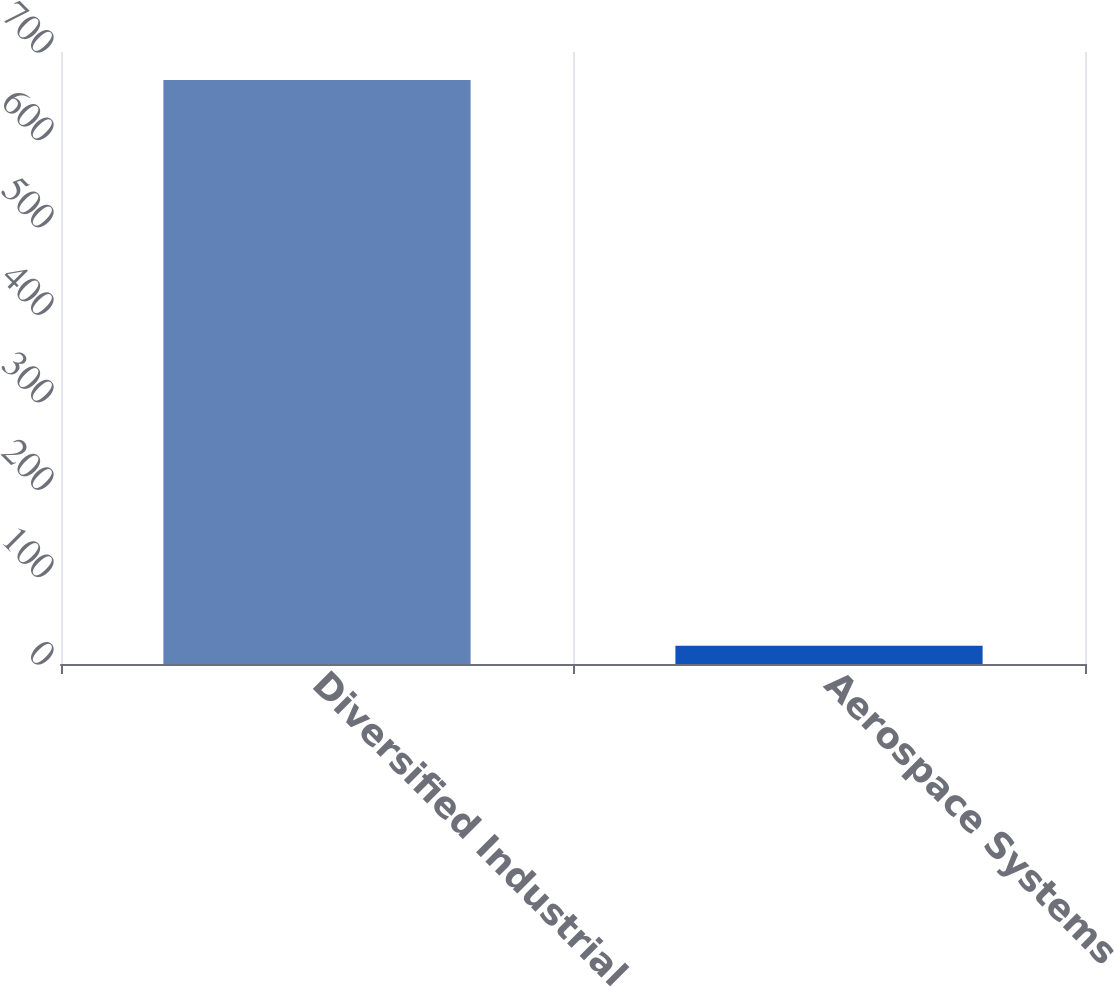Convert chart to OTSL. <chart><loc_0><loc_0><loc_500><loc_500><bar_chart><fcel>Diversified Industrial<fcel>Aerospace Systems<nl><fcel>668<fcel>21<nl></chart> 